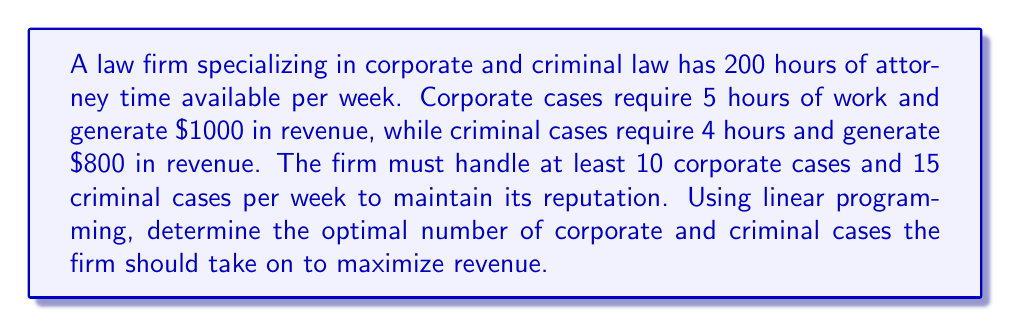Can you answer this question? Let's approach this step-by-step using linear programming:

1) Define variables:
   $x$ = number of corporate cases
   $y$ = number of criminal cases

2) Objective function (maximize revenue):
   $\text{Maximize } Z = 1000x + 800y$

3) Constraints:
   a) Time constraint: $5x + 4y \leq 200$ (total hours available)
   b) Minimum corporate cases: $x \geq 10$
   c) Minimum criminal cases: $y \geq 15$
   d) Non-negativity: $x, y \geq 0$

4) Set up the linear program:
   $$
   \begin{align*}
   \text{Maximize } & Z = 1000x + 800y \\
   \text{Subject to: } & 5x + 4y \leq 200 \\
   & x \geq 10 \\
   & y \geq 15 \\
   & x, y \geq 0
   \end{align*}
   $$

5) Solve graphically or using the simplex method. In this case, we can solve it by considering the corner points of the feasible region:

   - (10, 15): Z = 22,000
   - (10, 37.5): Z = 40,000
   - (25, 25): Z = 45,000
   - (40, 0): Z = 40,000

6) The optimal solution is at the point (25, 25), which maximizes Z at 45,000.

Therefore, the firm should take on 25 corporate cases and 25 criminal cases per week to maximize revenue.
Answer: 25 corporate cases, 25 criminal cases 